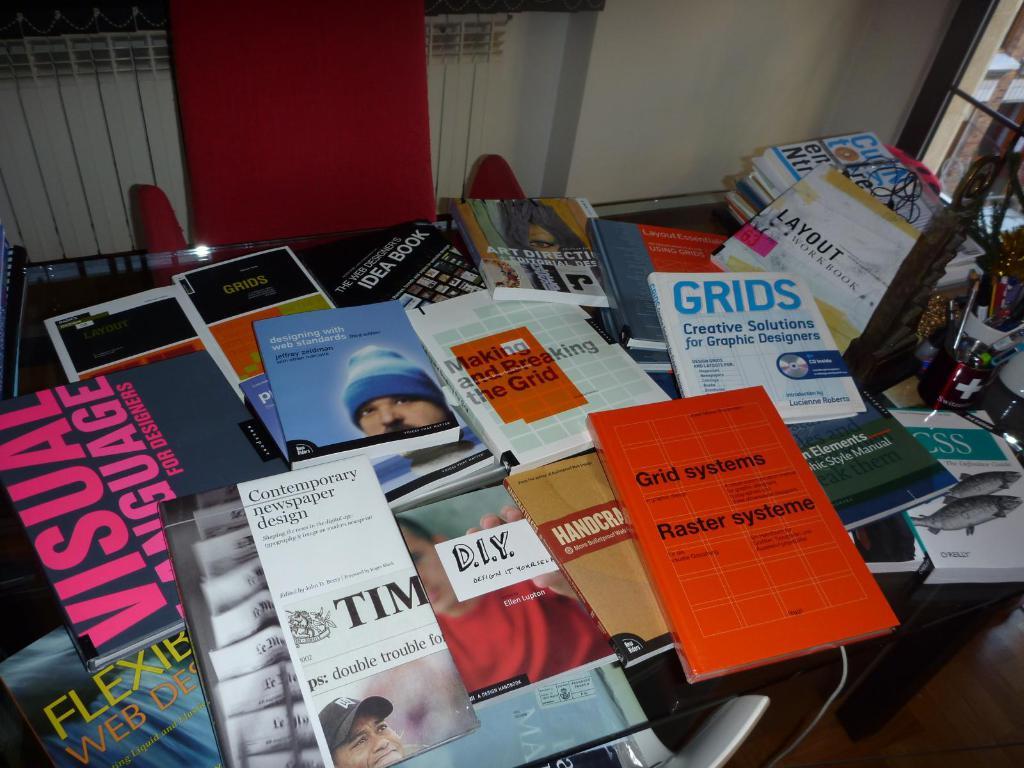What is the name of the book with the guy with the blue hat?
Make the answer very short. Designing with web standards. 